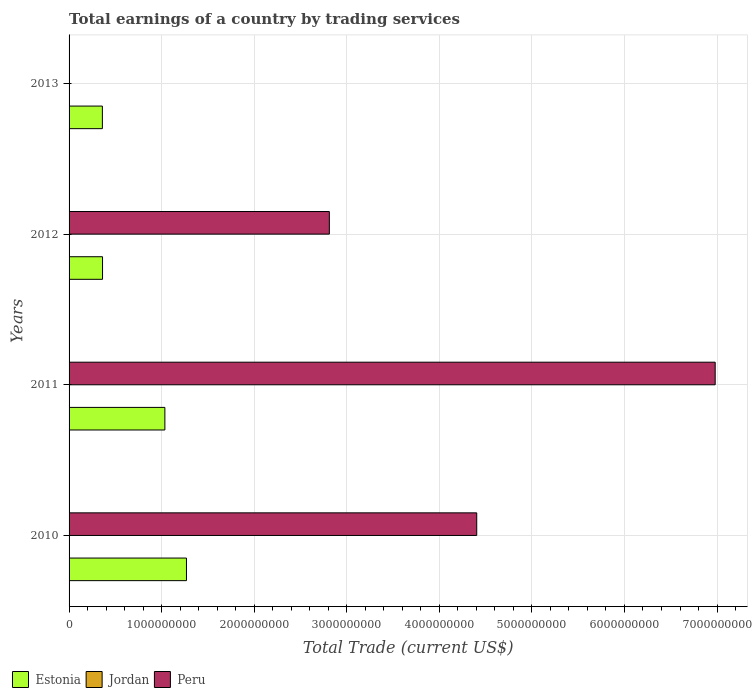Are the number of bars per tick equal to the number of legend labels?
Give a very brief answer. No. How many bars are there on the 1st tick from the bottom?
Offer a very short reply. 2. What is the label of the 3rd group of bars from the top?
Offer a terse response. 2011. In how many cases, is the number of bars for a given year not equal to the number of legend labels?
Your response must be concise. 4. Across all years, what is the maximum total earnings in Peru?
Offer a terse response. 6.98e+09. Across all years, what is the minimum total earnings in Estonia?
Keep it short and to the point. 3.60e+08. In which year was the total earnings in Estonia maximum?
Ensure brevity in your answer.  2010. What is the total total earnings in Peru in the graph?
Your response must be concise. 1.42e+1. What is the difference between the total earnings in Estonia in 2011 and that in 2012?
Ensure brevity in your answer.  6.74e+08. What is the difference between the total earnings in Peru in 2011 and the total earnings in Estonia in 2012?
Your answer should be very brief. 6.62e+09. What is the average total earnings in Peru per year?
Your answer should be compact. 3.55e+09. In the year 2012, what is the difference between the total earnings in Peru and total earnings in Estonia?
Offer a terse response. 2.45e+09. What is the ratio of the total earnings in Estonia in 2011 to that in 2013?
Ensure brevity in your answer.  2.88. What is the difference between the highest and the second highest total earnings in Peru?
Make the answer very short. 2.58e+09. Is it the case that in every year, the sum of the total earnings in Peru and total earnings in Jordan is greater than the total earnings in Estonia?
Your answer should be compact. No. Are all the bars in the graph horizontal?
Make the answer very short. Yes. Are the values on the major ticks of X-axis written in scientific E-notation?
Ensure brevity in your answer.  No. Does the graph contain any zero values?
Your answer should be compact. Yes. Does the graph contain grids?
Your response must be concise. Yes. Where does the legend appear in the graph?
Provide a succinct answer. Bottom left. How many legend labels are there?
Keep it short and to the point. 3. What is the title of the graph?
Provide a short and direct response. Total earnings of a country by trading services. Does "Turkey" appear as one of the legend labels in the graph?
Offer a very short reply. No. What is the label or title of the X-axis?
Offer a terse response. Total Trade (current US$). What is the Total Trade (current US$) of Estonia in 2010?
Provide a short and direct response. 1.27e+09. What is the Total Trade (current US$) in Jordan in 2010?
Give a very brief answer. 0. What is the Total Trade (current US$) in Peru in 2010?
Provide a short and direct response. 4.40e+09. What is the Total Trade (current US$) in Estonia in 2011?
Offer a very short reply. 1.04e+09. What is the Total Trade (current US$) of Jordan in 2011?
Offer a terse response. 0. What is the Total Trade (current US$) in Peru in 2011?
Ensure brevity in your answer.  6.98e+09. What is the Total Trade (current US$) in Estonia in 2012?
Give a very brief answer. 3.61e+08. What is the Total Trade (current US$) of Peru in 2012?
Provide a short and direct response. 2.81e+09. What is the Total Trade (current US$) of Estonia in 2013?
Make the answer very short. 3.60e+08. What is the Total Trade (current US$) of Peru in 2013?
Offer a very short reply. 0. Across all years, what is the maximum Total Trade (current US$) of Estonia?
Your response must be concise. 1.27e+09. Across all years, what is the maximum Total Trade (current US$) in Peru?
Offer a terse response. 6.98e+09. Across all years, what is the minimum Total Trade (current US$) of Estonia?
Make the answer very short. 3.60e+08. Across all years, what is the minimum Total Trade (current US$) in Peru?
Offer a terse response. 0. What is the total Total Trade (current US$) of Estonia in the graph?
Offer a terse response. 3.02e+09. What is the total Total Trade (current US$) of Jordan in the graph?
Provide a short and direct response. 0. What is the total Total Trade (current US$) of Peru in the graph?
Keep it short and to the point. 1.42e+1. What is the difference between the Total Trade (current US$) in Estonia in 2010 and that in 2011?
Give a very brief answer. 2.33e+08. What is the difference between the Total Trade (current US$) of Peru in 2010 and that in 2011?
Your answer should be compact. -2.58e+09. What is the difference between the Total Trade (current US$) of Estonia in 2010 and that in 2012?
Make the answer very short. 9.07e+08. What is the difference between the Total Trade (current US$) in Peru in 2010 and that in 2012?
Your response must be concise. 1.59e+09. What is the difference between the Total Trade (current US$) in Estonia in 2010 and that in 2013?
Offer a very short reply. 9.08e+08. What is the difference between the Total Trade (current US$) in Estonia in 2011 and that in 2012?
Provide a succinct answer. 6.74e+08. What is the difference between the Total Trade (current US$) of Peru in 2011 and that in 2012?
Provide a short and direct response. 4.17e+09. What is the difference between the Total Trade (current US$) in Estonia in 2011 and that in 2013?
Provide a short and direct response. 6.75e+08. What is the difference between the Total Trade (current US$) in Estonia in 2012 and that in 2013?
Provide a succinct answer. 1.66e+06. What is the difference between the Total Trade (current US$) in Estonia in 2010 and the Total Trade (current US$) in Peru in 2011?
Offer a very short reply. -5.71e+09. What is the difference between the Total Trade (current US$) of Estonia in 2010 and the Total Trade (current US$) of Peru in 2012?
Keep it short and to the point. -1.54e+09. What is the difference between the Total Trade (current US$) of Estonia in 2011 and the Total Trade (current US$) of Peru in 2012?
Make the answer very short. -1.78e+09. What is the average Total Trade (current US$) of Estonia per year?
Keep it short and to the point. 7.56e+08. What is the average Total Trade (current US$) of Jordan per year?
Your response must be concise. 0. What is the average Total Trade (current US$) of Peru per year?
Keep it short and to the point. 3.55e+09. In the year 2010, what is the difference between the Total Trade (current US$) in Estonia and Total Trade (current US$) in Peru?
Your response must be concise. -3.14e+09. In the year 2011, what is the difference between the Total Trade (current US$) of Estonia and Total Trade (current US$) of Peru?
Offer a terse response. -5.95e+09. In the year 2012, what is the difference between the Total Trade (current US$) of Estonia and Total Trade (current US$) of Peru?
Make the answer very short. -2.45e+09. What is the ratio of the Total Trade (current US$) in Estonia in 2010 to that in 2011?
Give a very brief answer. 1.23. What is the ratio of the Total Trade (current US$) of Peru in 2010 to that in 2011?
Give a very brief answer. 0.63. What is the ratio of the Total Trade (current US$) of Estonia in 2010 to that in 2012?
Give a very brief answer. 3.51. What is the ratio of the Total Trade (current US$) in Peru in 2010 to that in 2012?
Provide a short and direct response. 1.57. What is the ratio of the Total Trade (current US$) in Estonia in 2010 to that in 2013?
Provide a short and direct response. 3.52. What is the ratio of the Total Trade (current US$) in Estonia in 2011 to that in 2012?
Give a very brief answer. 2.86. What is the ratio of the Total Trade (current US$) in Peru in 2011 to that in 2012?
Your answer should be compact. 2.48. What is the ratio of the Total Trade (current US$) in Estonia in 2011 to that in 2013?
Keep it short and to the point. 2.88. What is the difference between the highest and the second highest Total Trade (current US$) in Estonia?
Your response must be concise. 2.33e+08. What is the difference between the highest and the second highest Total Trade (current US$) in Peru?
Your answer should be compact. 2.58e+09. What is the difference between the highest and the lowest Total Trade (current US$) of Estonia?
Your answer should be compact. 9.08e+08. What is the difference between the highest and the lowest Total Trade (current US$) in Peru?
Offer a terse response. 6.98e+09. 